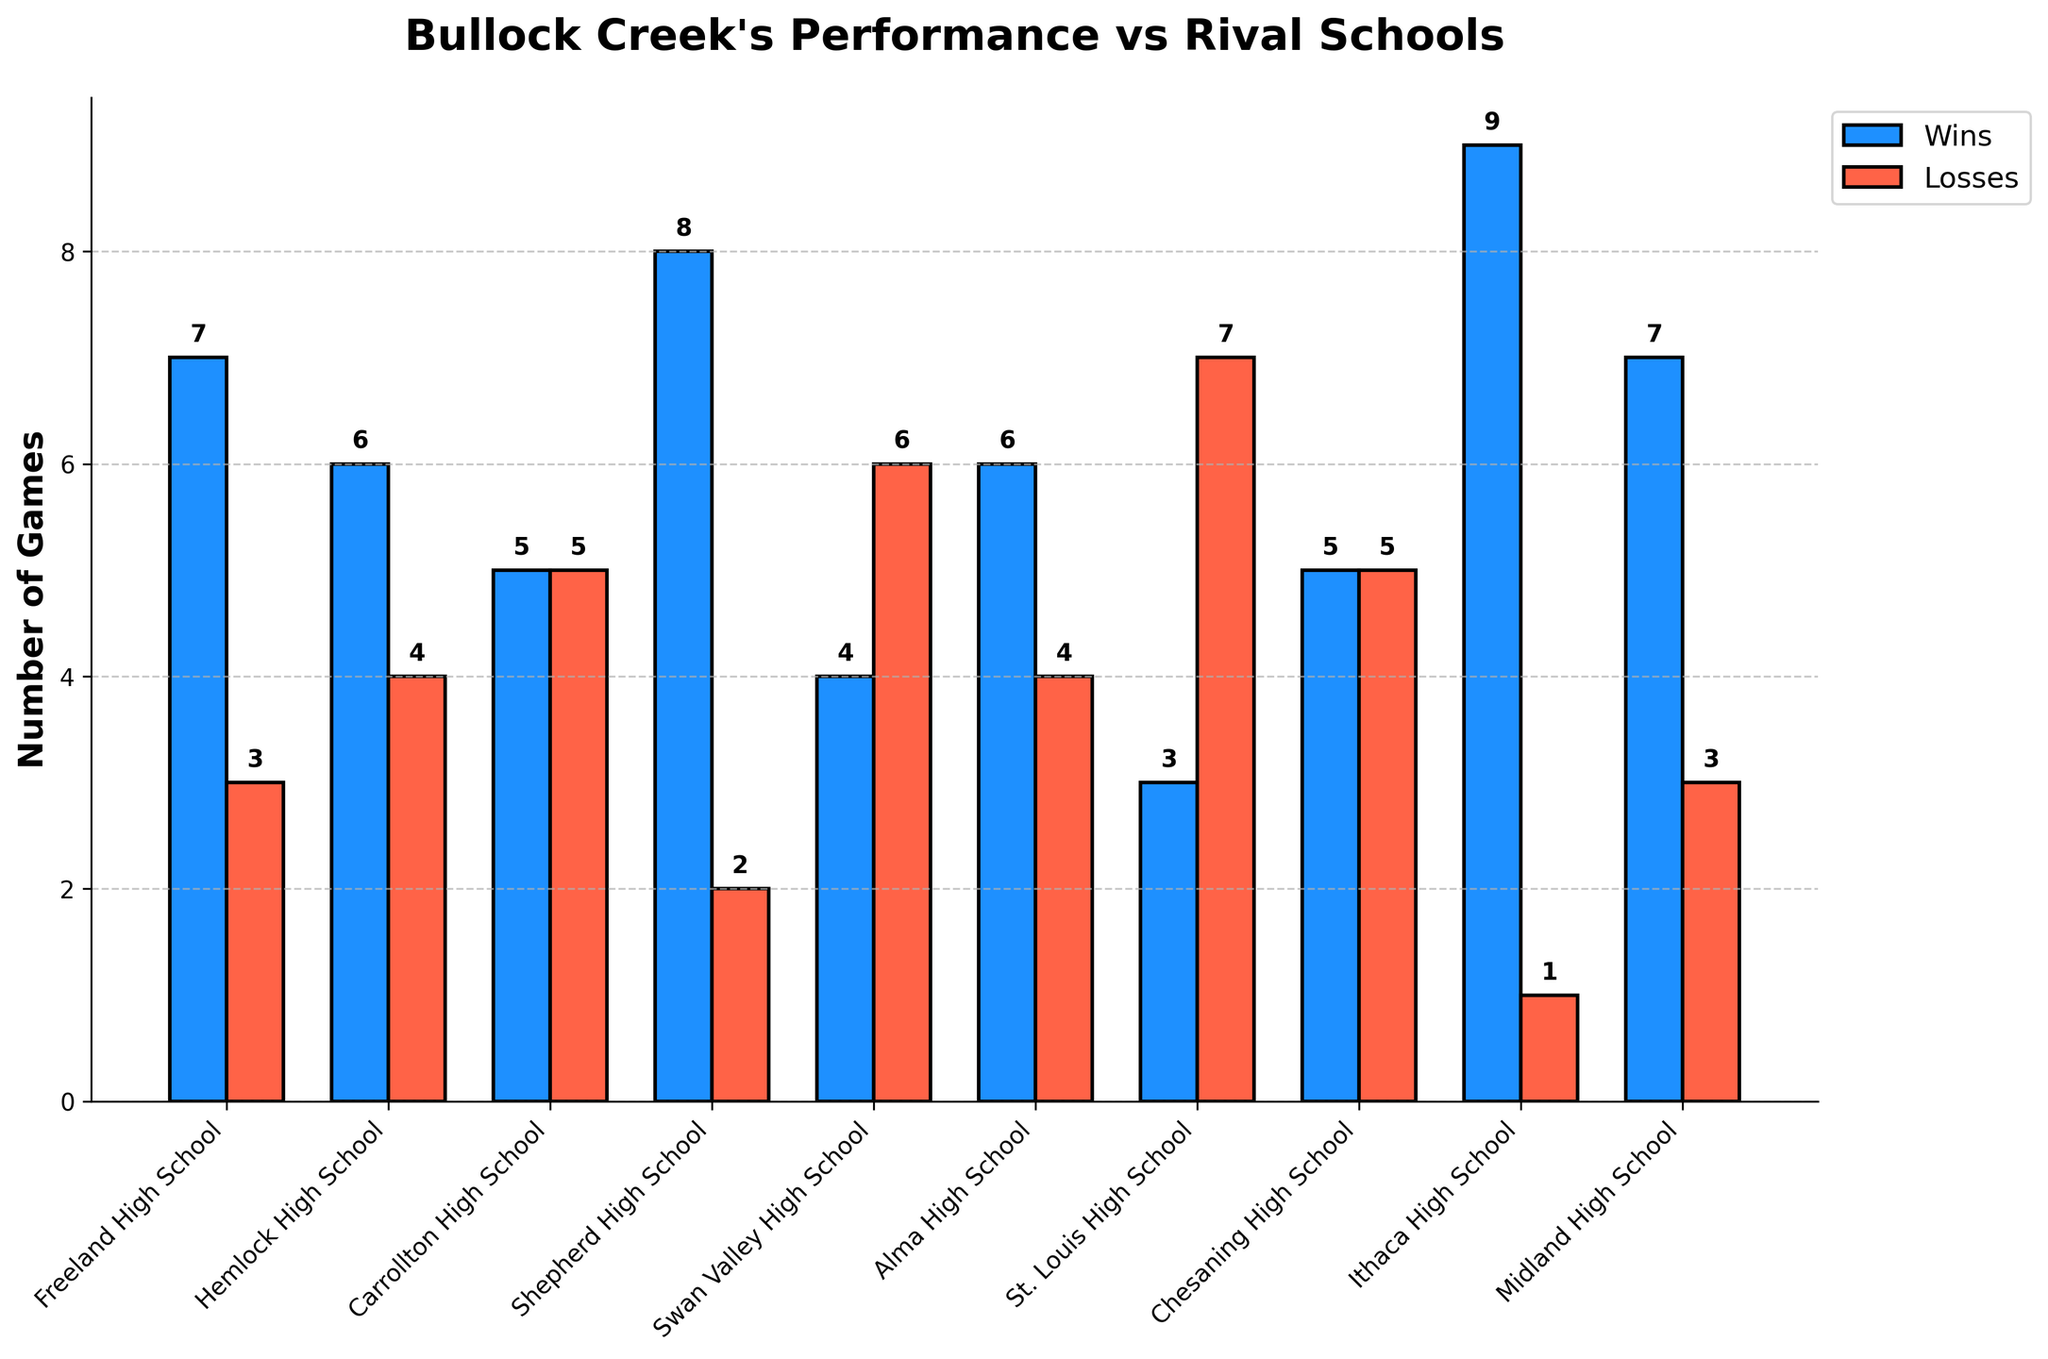Which school has the most wins? The school with the tallest blue bar represents the most wins. Ithaca High School has the tallest blue bar.
Answer: Ithaca High School Which school has the most losses? The school with the tallest red bar represents the most losses. St. Louis High School has the tallest red bar.
Answer: St. Louis High School How many more wins does Midland High School have compared to Swan Valley High School? Midland High School has a blue bar of height 7, and Swan Valley High School has a blue bar of height 4. The difference is 7 - 4.
Answer: 3 How many total games did Freeland High School play? The number of total games played is the sum of wins and losses. For Freeland High School, blue bar (wins) is 7 and red bar (losses) is 3, so 7 + 3.
Answer: 10 Which schools have an equal number of wins? Look for schools with blue bars of the same height. Carrollton High School and Chesaning High School both have blue bars of height 5.
Answer: Carrollton High School and Chesaning High School What is the average number of wins for all schools? Add the heights of all blue bars (7 + 6 + 5 + 8 + 4 + 6 + 3 + 5 + 9 + 7) and divide by the number of schools (10). The sum of wins is 60, so the average is 60/10.
Answer: 6 Which school has a better win-loss ratio, Hemlock High School or Alma High School? Calculate the win-loss ratio for both schools. Hemlock High: 6 wins and 4 losses, ratio is 6/4 = 1.5. Alma High: 6 wins and 4 losses, ratio is 6/4 = 1.5. They have the same ratio.
Answer: They have the same ratio How many less losses does Shepherd High School have compared to St. Louis High School? Shepherd High School has 2 losses (red bar height) and St. Louis High School has 7 losses (red bar height). The difference is 7 - 2.
Answer: 5 Which school scored the second highest points? From the table, the school with the second highest points scored is Midland High School with 215 points.
Answer: Midland High School 